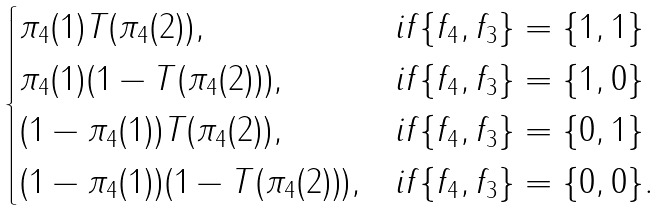<formula> <loc_0><loc_0><loc_500><loc_500>\begin{cases} \pi _ { 4 } ( 1 ) T ( \pi _ { 4 } ( 2 ) ) , & i f \{ f _ { 4 } , f _ { 3 } \} = \{ 1 , 1 \} \\ \pi _ { 4 } ( 1 ) ( 1 - T ( \pi _ { 4 } ( 2 ) ) ) , & i f \{ f _ { 4 } , f _ { 3 } \} = \{ 1 , 0 \} \\ ( 1 - \pi _ { 4 } ( 1 ) ) T ( \pi _ { 4 } ( 2 ) ) , & i f \{ f _ { 4 } , f _ { 3 } \} = \{ 0 , 1 \} \\ ( 1 - \pi _ { 4 } ( 1 ) ) ( 1 - T ( \pi _ { 4 } ( 2 ) ) ) , & i f \{ f _ { 4 } , f _ { 3 } \} = \{ 0 , 0 \} . \end{cases}</formula> 